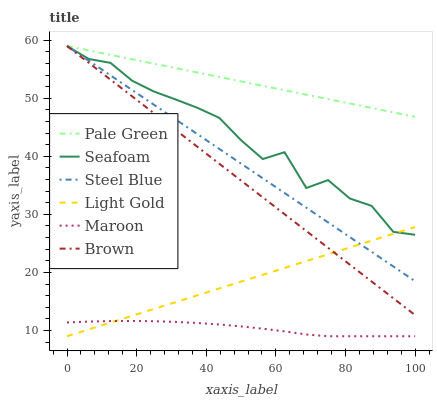Does Maroon have the minimum area under the curve?
Answer yes or no. Yes. Does Pale Green have the maximum area under the curve?
Answer yes or no. Yes. Does Seafoam have the minimum area under the curve?
Answer yes or no. No. Does Seafoam have the maximum area under the curve?
Answer yes or no. No. Is Light Gold the smoothest?
Answer yes or no. Yes. Is Seafoam the roughest?
Answer yes or no. Yes. Is Maroon the smoothest?
Answer yes or no. No. Is Maroon the roughest?
Answer yes or no. No. Does Seafoam have the lowest value?
Answer yes or no. No. Does Pale Green have the highest value?
Answer yes or no. Yes. Does Seafoam have the highest value?
Answer yes or no. No. Is Maroon less than Steel Blue?
Answer yes or no. Yes. Is Pale Green greater than Seafoam?
Answer yes or no. Yes. Does Steel Blue intersect Brown?
Answer yes or no. Yes. Is Steel Blue less than Brown?
Answer yes or no. No. Is Steel Blue greater than Brown?
Answer yes or no. No. Does Maroon intersect Steel Blue?
Answer yes or no. No. 